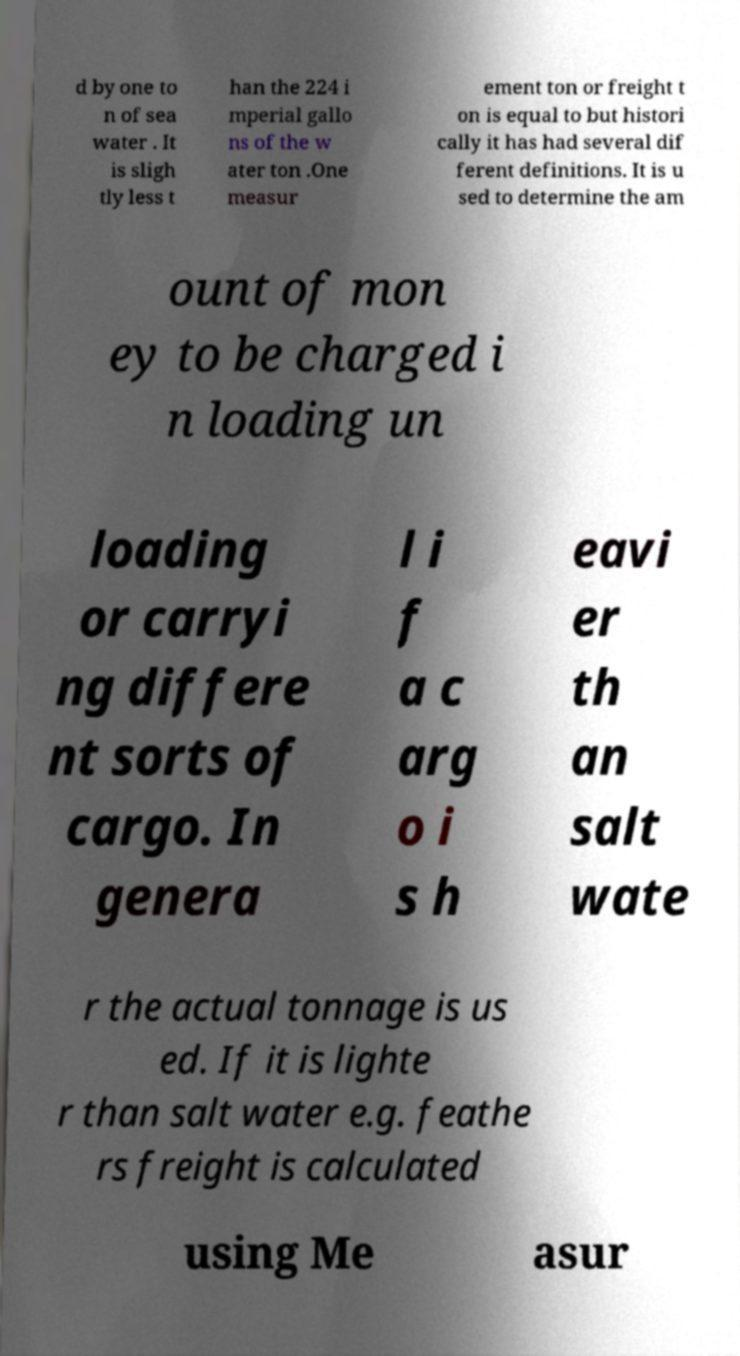I need the written content from this picture converted into text. Can you do that? d by one to n of sea water . It is sligh tly less t han the 224 i mperial gallo ns of the w ater ton .One measur ement ton or freight t on is equal to but histori cally it has had several dif ferent definitions. It is u sed to determine the am ount of mon ey to be charged i n loading un loading or carryi ng differe nt sorts of cargo. In genera l i f a c arg o i s h eavi er th an salt wate r the actual tonnage is us ed. If it is lighte r than salt water e.g. feathe rs freight is calculated using Me asur 